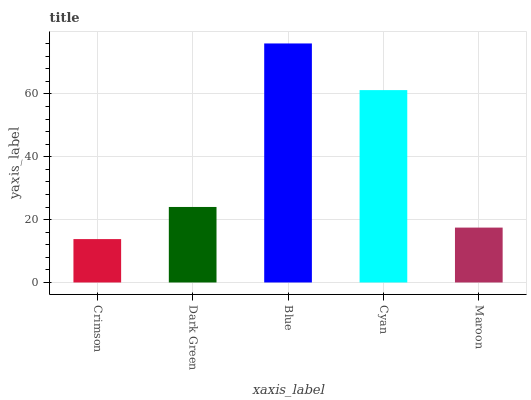Is Dark Green the minimum?
Answer yes or no. No. Is Dark Green the maximum?
Answer yes or no. No. Is Dark Green greater than Crimson?
Answer yes or no. Yes. Is Crimson less than Dark Green?
Answer yes or no. Yes. Is Crimson greater than Dark Green?
Answer yes or no. No. Is Dark Green less than Crimson?
Answer yes or no. No. Is Dark Green the high median?
Answer yes or no. Yes. Is Dark Green the low median?
Answer yes or no. Yes. Is Maroon the high median?
Answer yes or no. No. Is Blue the low median?
Answer yes or no. No. 